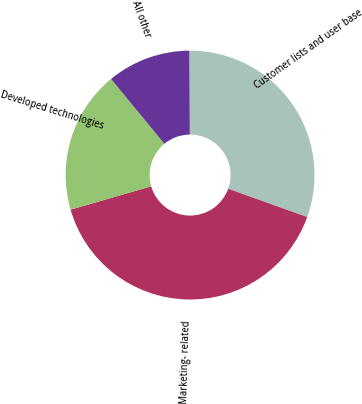<chart> <loc_0><loc_0><loc_500><loc_500><pie_chart><fcel>Customer lists and user base<fcel>Marketing- related<fcel>Developed technologies<fcel>All other<nl><fcel>30.58%<fcel>40.03%<fcel>18.53%<fcel>10.85%<nl></chart> 